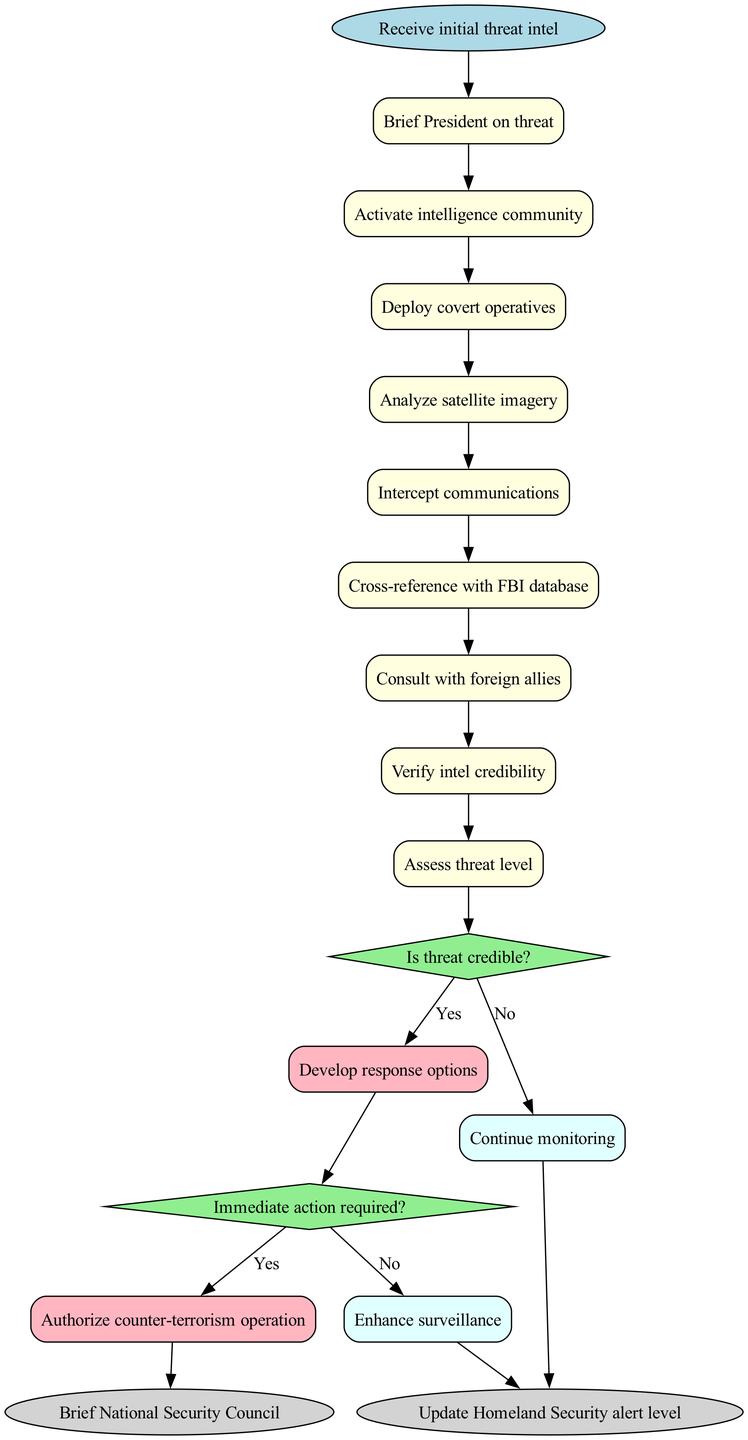What is the first activity after receiving initial threat intel? The diagram shows that after the start node, which is "Receive initial threat intel", the first activity is "Brief President on threat".
Answer: Brief President on threat How many decision nodes are present in the diagram? By examining the diagram, there are two decision nodes labeled "Is threat credible?" and "Immediate action required?", thus there are 2 decision nodes in total.
Answer: 2 What happens if the threat is deemed credible? The flow shows that if the threat is credible (the "yes" path of the first decision), the next step is to "Develop response options".
Answer: Develop response options What activities lead to the final end nodes? Tracing the diagram reveals that two activities can lead to the end nodes: one from "Authorize counter-terrorism operation", and another from "Update Homeland Security alert level" following "Continue monitoring".
Answer: Authorize counter-terrorism operation and Update Homeland Security alert level What is the last activity before checking the credibility of the threat? The last activity preceding the decision node about threat credibility is "Cross-reference with FBI database".
Answer: Cross-reference with FBI database What action follows the decision if immediate action is not required? If the decision indicates that immediate action is not required, the next step in the flow is "Enhance surveillance".
Answer: Enhance surveillance Which activity involves consulting external parties? The diagram indicates an activity labeled "Consult with foreign allies" which is specifically about reaching out to external parties for intelligence.
Answer: Consult with foreign allies What is the second activity in the flow after starting with initial threat intel? Following "Brief President on threat," the second activity listed in the diagram is "Activate intelligence community".
Answer: Activate intelligence community 